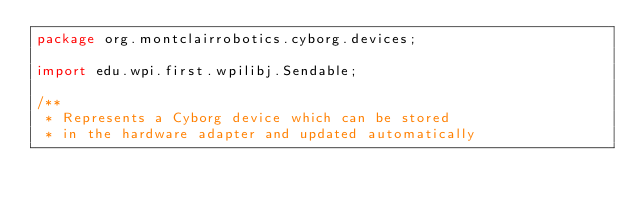Convert code to text. <code><loc_0><loc_0><loc_500><loc_500><_Java_>package org.montclairrobotics.cyborg.devices;

import edu.wpi.first.wpilibj.Sendable;

/**
 * Represents a Cyborg device which can be stored
 * in the hardware adapter and updated automatically</code> 